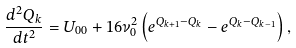<formula> <loc_0><loc_0><loc_500><loc_500>\frac { d ^ { 2 } Q _ { k } } { d t ^ { 2 } } = U _ { 0 0 } + 1 6 \nu _ { 0 } ^ { 2 } \left ( e ^ { Q _ { k + 1 } - Q _ { k } } - e ^ { Q _ { k } - Q _ { k - 1 } } \right ) ,</formula> 